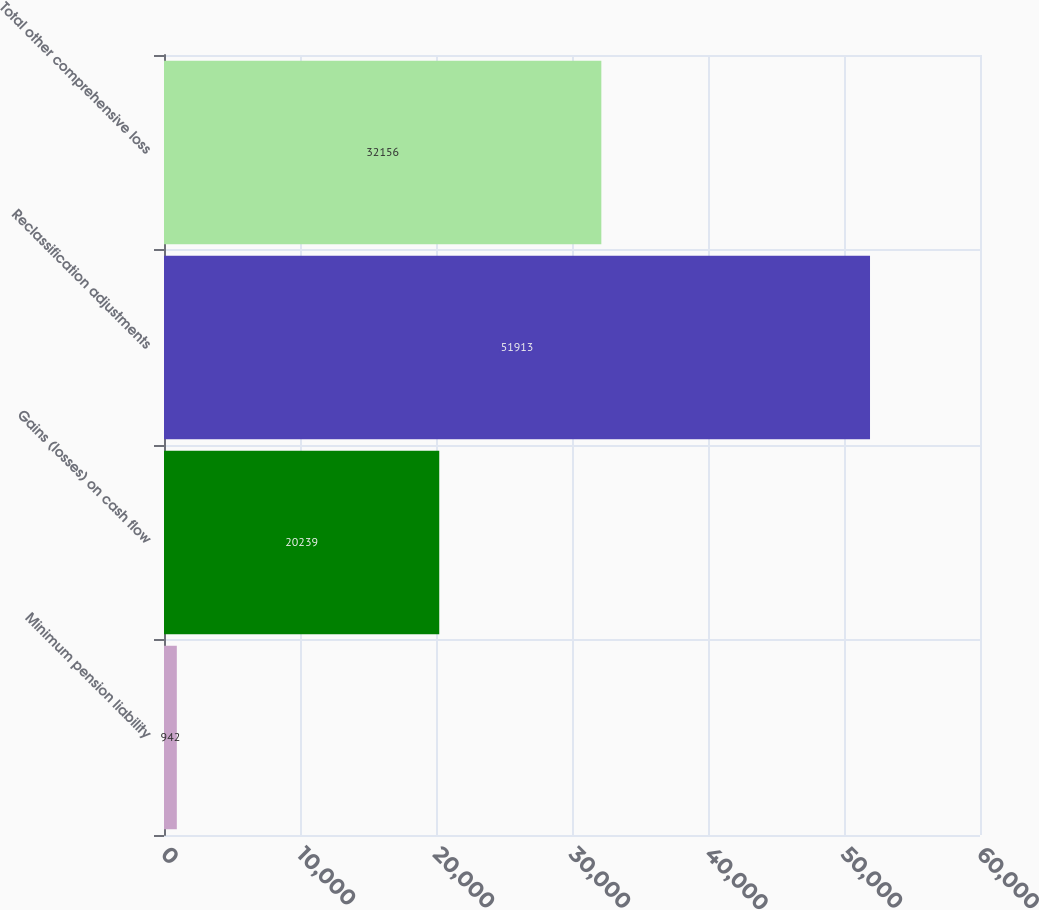<chart> <loc_0><loc_0><loc_500><loc_500><bar_chart><fcel>Minimum pension liability<fcel>Gains (losses) on cash flow<fcel>Reclassification adjustments<fcel>Total other comprehensive loss<nl><fcel>942<fcel>20239<fcel>51913<fcel>32156<nl></chart> 